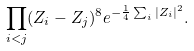<formula> <loc_0><loc_0><loc_500><loc_500>\prod _ { i < j } ( Z _ { i } - Z _ { j } ) ^ { 8 } e ^ { - \frac { 1 } { 4 } \sum _ { i } | Z _ { i } | ^ { 2 } } .</formula> 